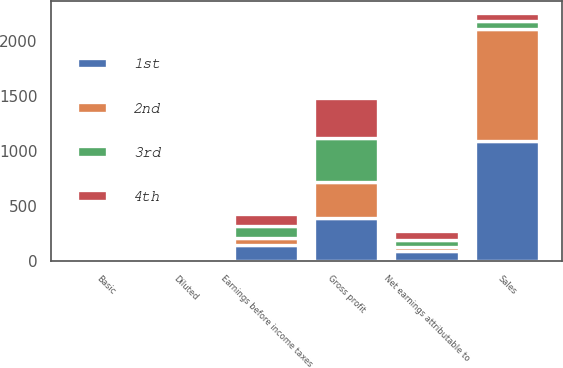Convert chart. <chart><loc_0><loc_0><loc_500><loc_500><stacked_bar_chart><ecel><fcel>Sales<fcel>Gross profit<fcel>Earnings before income taxes<fcel>Net earnings attributable to<fcel>Basic<fcel>Diluted<nl><fcel>3rd<fcel>73.2<fcel>397.7<fcel>109.8<fcel>71.4<fcel>0.55<fcel>0.54<nl><fcel>1st<fcel>1096.5<fcel>388.8<fcel>146.6<fcel>93.6<fcel>0.71<fcel>0.7<nl><fcel>4th<fcel>73.2<fcel>369.1<fcel>107.6<fcel>75<fcel>0.56<fcel>0.56<nl><fcel>2nd<fcel>1014.6<fcel>331.7<fcel>58.2<fcel>27.7<fcel>0.21<fcel>0.2<nl></chart> 